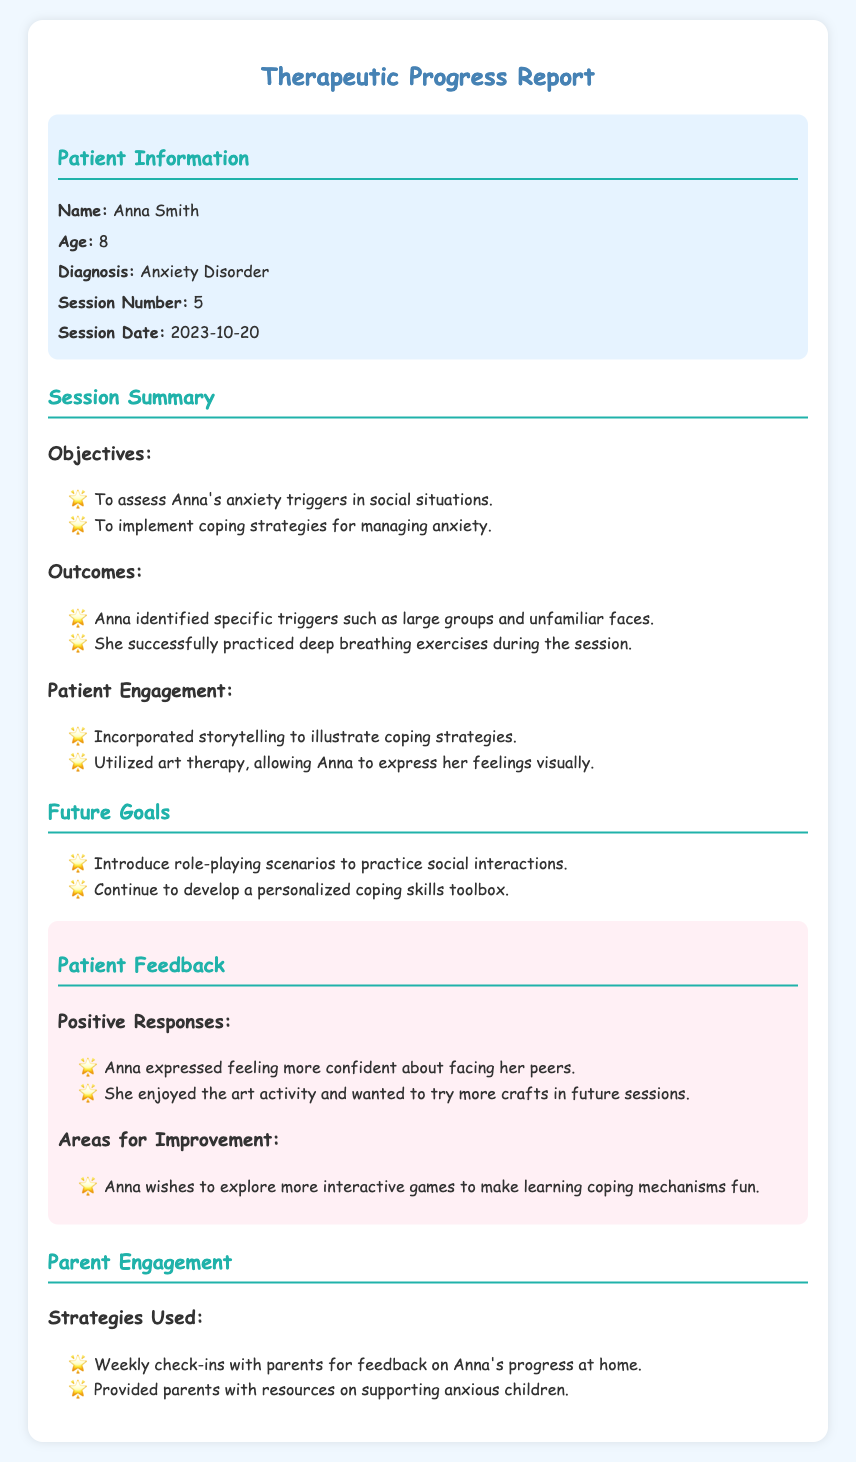What is the patient's name? The patient's name is found in the patient information section of the document.
Answer: Anna Smith What is the patient's age? The age of the patient is listed alongside their name in the document.
Answer: 8 What diagnosis does Anna have? The document indicates Anna's diagnosis in the patient information section.
Answer: Anxiety Disorder How many sessions have been completed? The session number is provided in the patient information section.
Answer: 5 What is one identified trigger for Anna's anxiety? This information is found in the outcomes section of the session summary.
Answer: Large groups What coping strategy did Anna successfully practice? The outcomes section describes the coping strategies practiced during the session.
Answer: Deep breathing exercises What future goal involves practicing social interactions? The future goals section outlines specific objectives for upcoming sessions.
Answer: Role-playing scenarios What type of feedback did Anna provide about the art activity? Anna's feedback about the activity is recorded under patient feedback.
Answer: Enjoyed the art activity What is one strategy used for parent engagement? The parent engagement strategies are listed in the corresponding section of the document.
Answer: Weekly check-ins with parents 